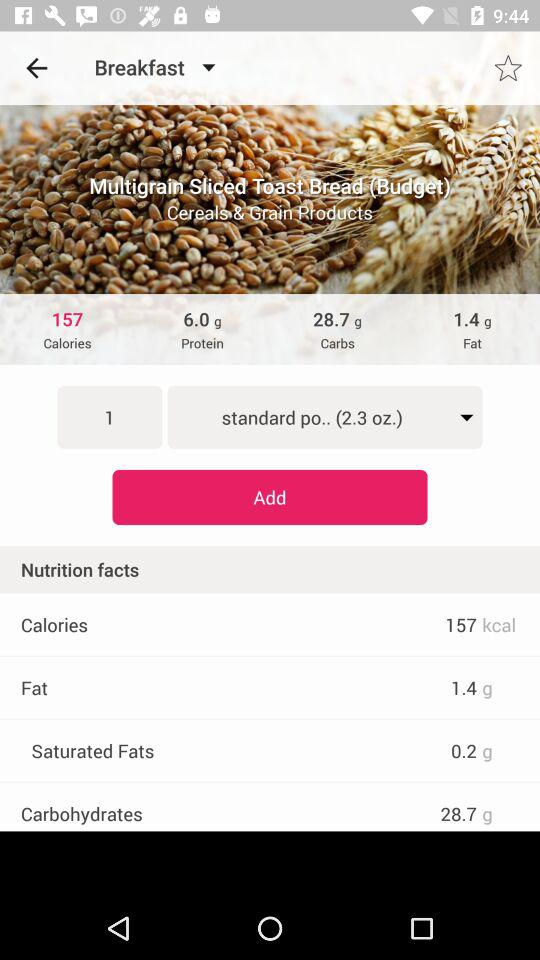How many grams of saturated fat does one serving of this food have?
Answer the question using a single word or phrase. 0.2 g 